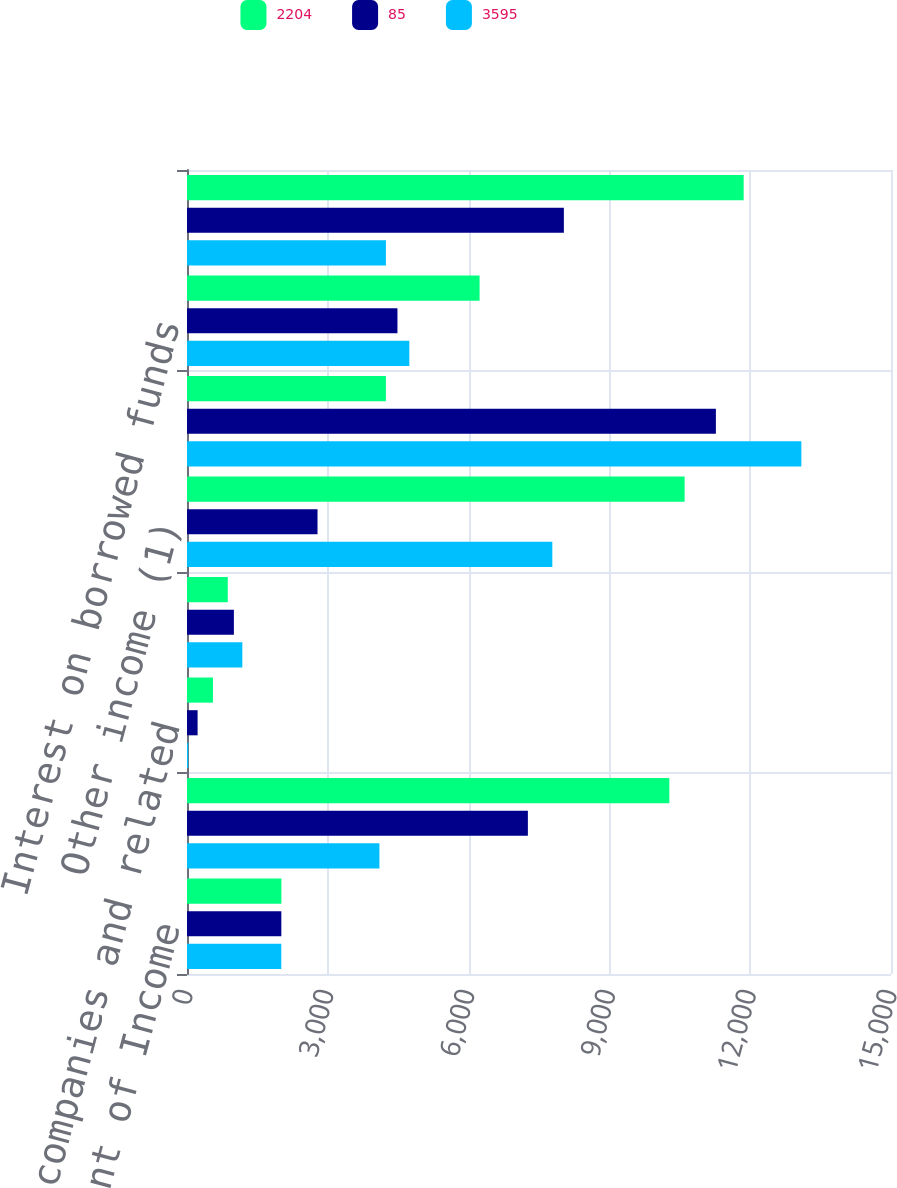<chart> <loc_0><loc_0><loc_500><loc_500><stacked_bar_chart><ecel><fcel>Condensed Statement of Income<fcel>Bank holding companies and<fcel>Nonbank companies and related<fcel>Interest from subsidiaries<fcel>Other income (1)<fcel>Total income<fcel>Interest on borrowed funds<fcel>Noninterest expense (2)<nl><fcel>2204<fcel>2011<fcel>10277<fcel>553<fcel>869<fcel>10603<fcel>4238<fcel>6234<fcel>11861<nl><fcel>85<fcel>2010<fcel>7263<fcel>226<fcel>999<fcel>2781<fcel>11269<fcel>4484<fcel>8030<nl><fcel>3595<fcel>2009<fcel>4100<fcel>27<fcel>1179<fcel>7784<fcel>13090<fcel>4737<fcel>4238<nl></chart> 